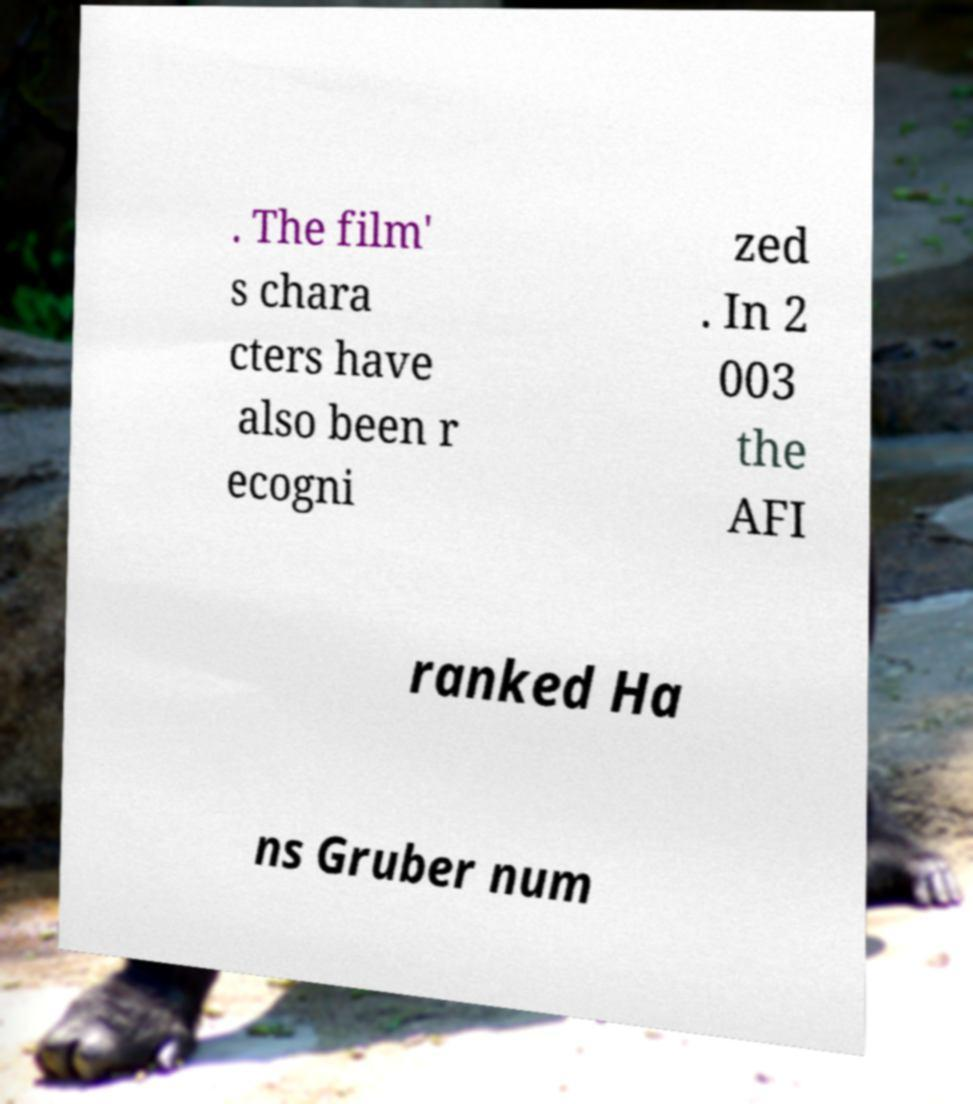Could you assist in decoding the text presented in this image and type it out clearly? . The film' s chara cters have also been r ecogni zed . In 2 003 the AFI ranked Ha ns Gruber num 